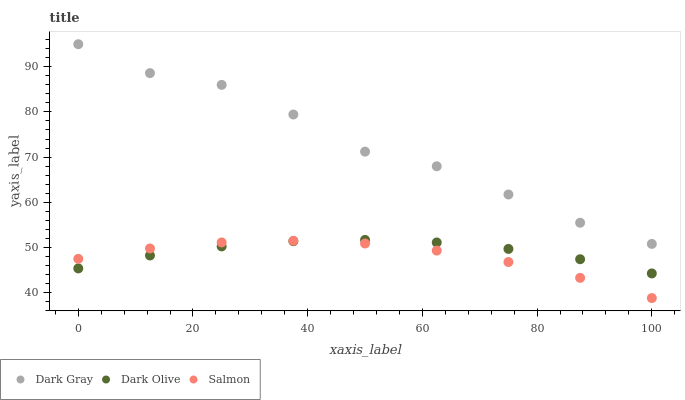Does Salmon have the minimum area under the curve?
Answer yes or no. Yes. Does Dark Gray have the maximum area under the curve?
Answer yes or no. Yes. Does Dark Olive have the minimum area under the curve?
Answer yes or no. No. Does Dark Olive have the maximum area under the curve?
Answer yes or no. No. Is Dark Olive the smoothest?
Answer yes or no. Yes. Is Dark Gray the roughest?
Answer yes or no. Yes. Is Salmon the smoothest?
Answer yes or no. No. Is Salmon the roughest?
Answer yes or no. No. Does Salmon have the lowest value?
Answer yes or no. Yes. Does Dark Olive have the lowest value?
Answer yes or no. No. Does Dark Gray have the highest value?
Answer yes or no. Yes. Does Dark Olive have the highest value?
Answer yes or no. No. Is Salmon less than Dark Gray?
Answer yes or no. Yes. Is Dark Gray greater than Salmon?
Answer yes or no. Yes. Does Salmon intersect Dark Olive?
Answer yes or no. Yes. Is Salmon less than Dark Olive?
Answer yes or no. No. Is Salmon greater than Dark Olive?
Answer yes or no. No. Does Salmon intersect Dark Gray?
Answer yes or no. No. 